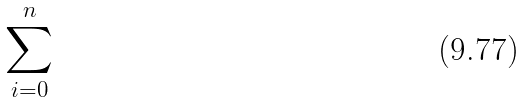Convert formula to latex. <formula><loc_0><loc_0><loc_500><loc_500>\sum _ { i = 0 } ^ { n }</formula> 